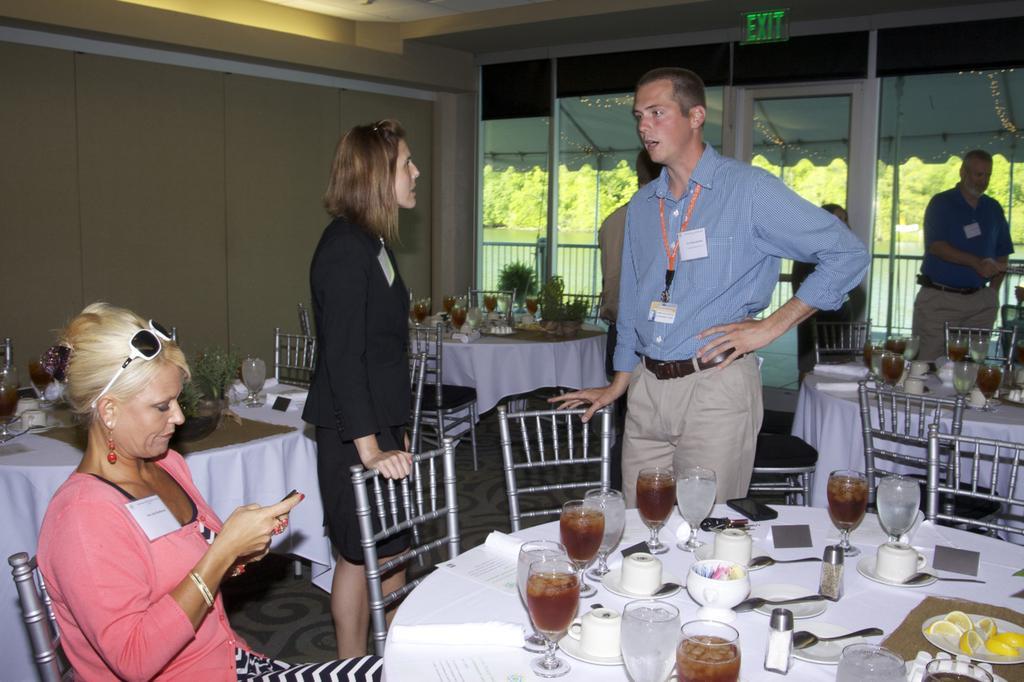Can you describe this image briefly? In this picture to the left ,there is a woman who is wearing a pink dress is sitting on the chair. There is also another woman who is wearing a black dress is standing. There is a man who is wearing a blue shirt is also standing. There is a glass, a cup and a saucer on the table. There is a spoon. There are some lemons on the plate. There is a chair. At the background, there is also another man who is wearing a blue t shirt is standing. At the background, there is a flower pot. There is a fork on the table. There is a paper on the table. 